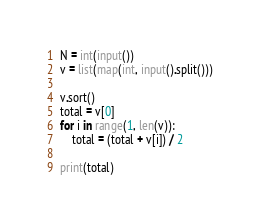Convert code to text. <code><loc_0><loc_0><loc_500><loc_500><_Python_>N = int(input())
v = list(map(int, input().split()))

v.sort()
total = v[0]
for i in range(1, len(v)):
    total = (total + v[i]) / 2
    
print(total)</code> 